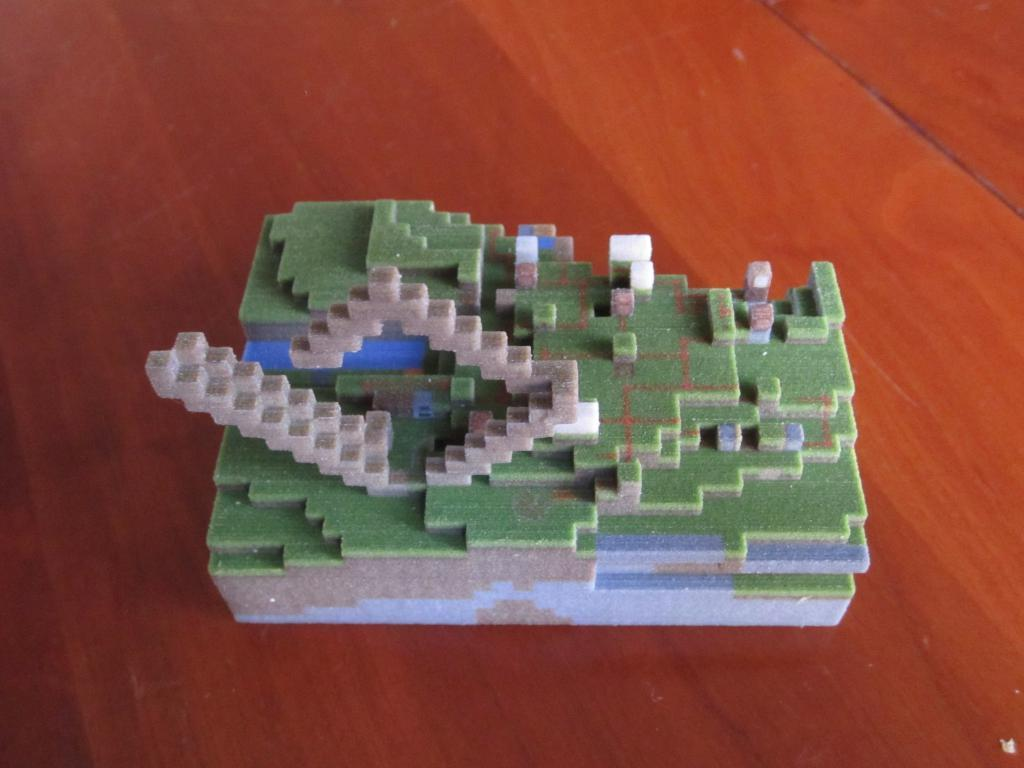What type of object is depicted in the image? The image consists of a miniature. What material is the miniature made of? The miniature appears to be made of wax. What is the base of the image? There is a floor at the bottom of the image. What type of book is being used as a vessel in the image? There is no book or vessel present in the image; it features a wax miniature on a floor. Is there a mask visible on the miniature in the image? There is no mask present on the miniature in the image. 